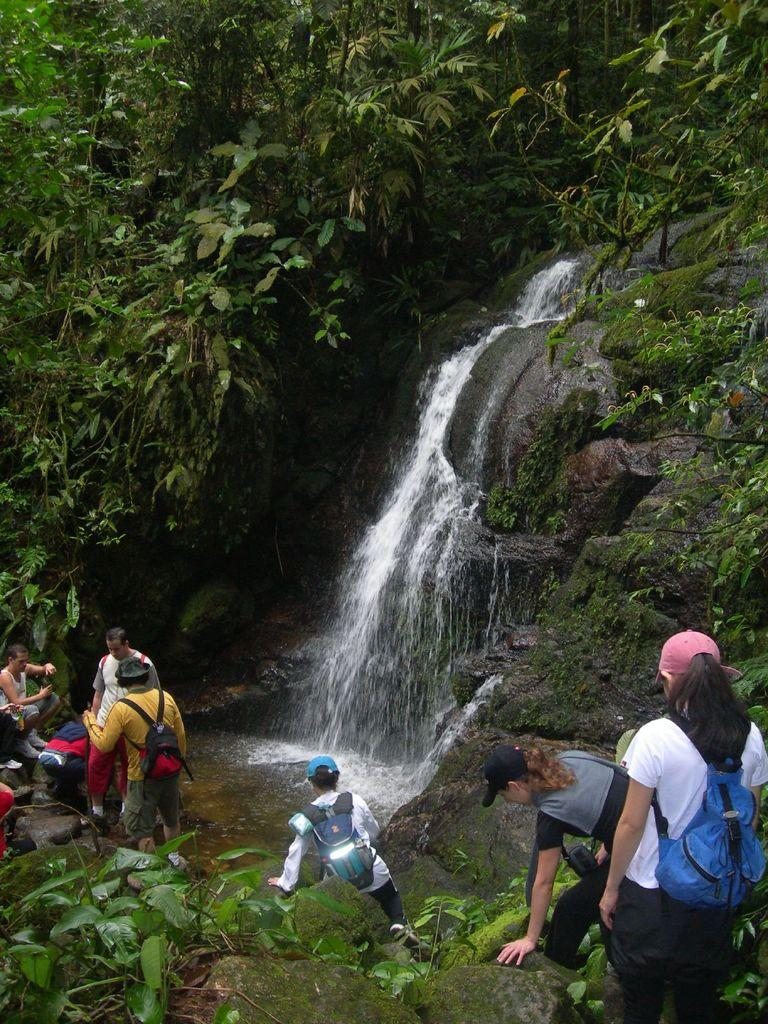What natural feature is the main subject of the image? There is a waterfall in the image. What type of vegetation can be seen in the top left of the image? There is a group of trees in the top left of the image. What can be seen at the bottom of the image? There are people and rocks visible at the bottom of the image. What type of plants are on the right side of the image? There are plants on the right side of the image. How many bikes are parked near the waterfall in the image? There are no bikes present in the image. What type of respect can be observed among the people near the waterfall in the image? There is no indication of respect or any social interaction among the people in the image. 